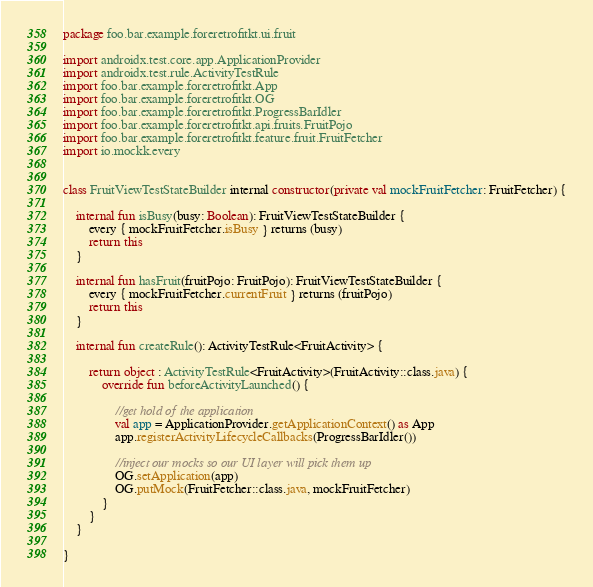Convert code to text. <code><loc_0><loc_0><loc_500><loc_500><_Kotlin_>
package foo.bar.example.foreretrofitkt.ui.fruit

import androidx.test.core.app.ApplicationProvider
import androidx.test.rule.ActivityTestRule
import foo.bar.example.foreretrofitkt.App
import foo.bar.example.foreretrofitkt.OG
import foo.bar.example.foreretrofitkt.ProgressBarIdler
import foo.bar.example.foreretrofitkt.api.fruits.FruitPojo
import foo.bar.example.foreretrofitkt.feature.fruit.FruitFetcher
import io.mockk.every


class FruitViewTestStateBuilder internal constructor(private val mockFruitFetcher: FruitFetcher) {

    internal fun isBusy(busy: Boolean): FruitViewTestStateBuilder {
        every { mockFruitFetcher.isBusy } returns (busy)
        return this
    }

    internal fun hasFruit(fruitPojo: FruitPojo): FruitViewTestStateBuilder {
        every { mockFruitFetcher.currentFruit } returns (fruitPojo)
        return this
    }

    internal fun createRule(): ActivityTestRule<FruitActivity> {

        return object : ActivityTestRule<FruitActivity>(FruitActivity::class.java) {
            override fun beforeActivityLaunched() {

                //get hold of the application
                val app = ApplicationProvider.getApplicationContext() as App
                app.registerActivityLifecycleCallbacks(ProgressBarIdler())

                //inject our mocks so our UI layer will pick them up
                OG.setApplication(app)
                OG.putMock(FruitFetcher::class.java, mockFruitFetcher)
            }
        }
    }

}
</code> 